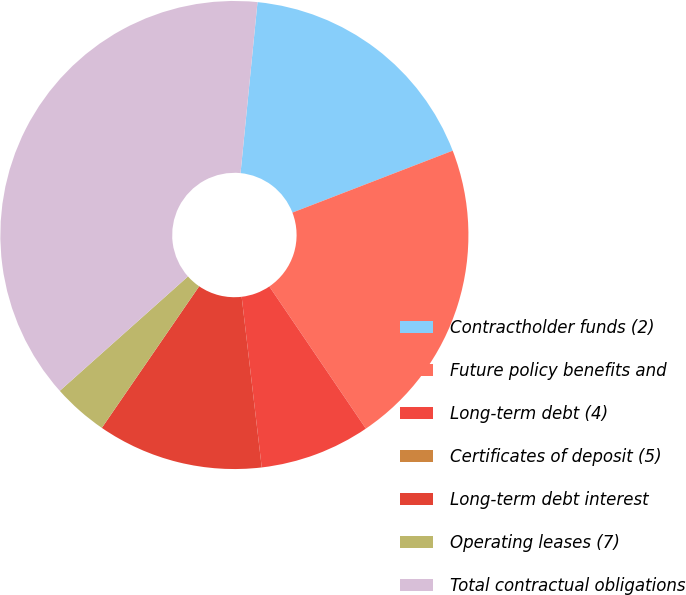Convert chart to OTSL. <chart><loc_0><loc_0><loc_500><loc_500><pie_chart><fcel>Contractholder funds (2)<fcel>Future policy benefits and<fcel>Long-term debt (4)<fcel>Certificates of deposit (5)<fcel>Long-term debt interest<fcel>Operating leases (7)<fcel>Total contractual obligations<nl><fcel>17.56%<fcel>21.37%<fcel>7.63%<fcel>0.0%<fcel>11.45%<fcel>3.82%<fcel>38.17%<nl></chart> 